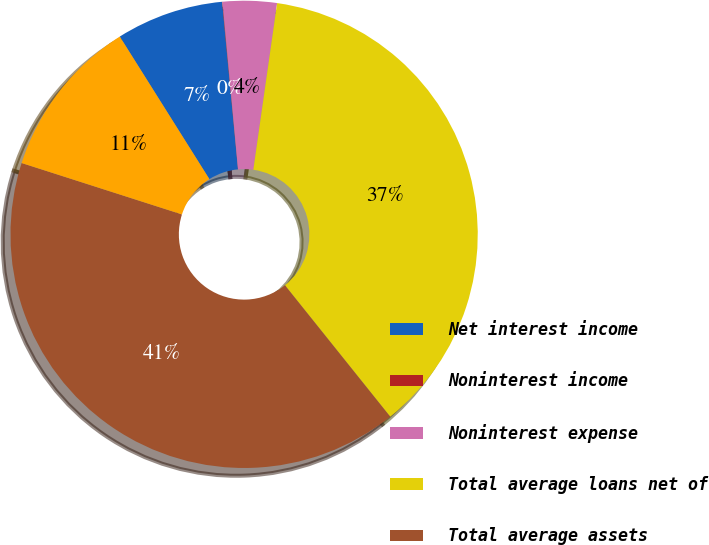Convert chart to OTSL. <chart><loc_0><loc_0><loc_500><loc_500><pie_chart><fcel>Net interest income<fcel>Noninterest income<fcel>Noninterest expense<fcel>Total average loans net of<fcel>Total average assets<fcel>Total average deposits<nl><fcel>7.43%<fcel>0.03%<fcel>3.73%<fcel>36.99%<fcel>40.69%<fcel>11.13%<nl></chart> 